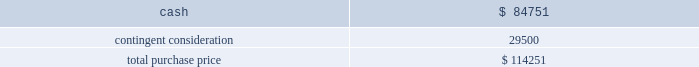Table of contents the company concluded that the acquisition of sentinelle medical did not represent a material business combination , and therefore , no pro forma financial information has been provided herein .
Subsequent to the acquisition date , the company 2019s results of operations include the results of sentinelle medical , which is included within the company 2019s breast health reporting segment .
The company accounted for the sentinelle medical acquisition as a purchase of a business under asc 805 .
The purchase price was comprised of an $ 84.8 million cash payment , which was net of certain adjustments , plus three contingent payments up to a maximum of an additional $ 250.0 million in cash .
The contingent payments are based on a multiple of incremental revenue growth during the two-year period following the completion of the acquisition as follows : six months after acquisition , 12 months after acquisition , and 24 months after acquisition .
Pursuant to asc 805 , the company recorded its estimate of the fair value of the contingent consideration liability based on future revenue projections of the sentinelle medical business under various potential scenarios and weighted probability assumptions of these outcomes .
As of the date of acquisition , these cash flow projections were discounted using a rate of 16.5% ( 16.5 % ) .
The discount rate is based on the weighted-average cost of capital of the acquired business plus a credit risk premium for non-performance risk related to the liability pursuant to asc 820 .
This analysis resulted in an initial contingent consideration liability of $ 29.5 million , which will be adjusted periodically as a component of operating expenses based on changes in the fair value of the liability driven by the accretion of the liability for the time value of money and changes in the assumptions pertaining to the achievement of the defined revenue growth milestones .
This fair value measurement was based on significant inputs not observable in the market and thus represented a level 3 measurement as defined in asc during each quarter in fiscal 2011 , the company has re-evaluated its assumptions and updated the revenue and probability assumptions for future earn-out periods and lowered its projections .
As a result of these adjustments , which were partially offset by the accretion of the liability , and using a current discount rate of approximately 17.0% ( 17.0 % ) , the company recorded a reversal of expense of $ 14.3 million in fiscal 2011 to record the contingent consideration liability at fair value .
In addition , during the second quarter of fiscal 2011 , the first earn-out period ended , and the company adjusted the fair value of the contingent consideration liability for actual results during the earn-out period .
This payment of $ 4.3 million was made in the third quarter of fiscal 2011 .
At september 24 , 2011 , the fair value of the liability is $ 10.9 million .
The company did not issue any equity awards in connection with this acquisition .
The company incurred third-party transaction costs of $ 1.2 million , which were expensed within general and administrative expenses in fiscal 2010 .
The purchase price was as follows: .
Source : hologic inc , 10-k , november 23 , 2011 powered by morningstar ae document research 2120 the information contained herein may not be copied , adapted or distributed and is not warranted to be accurate , complete or timely .
The user assumes all risks for any damages or losses arising from any use of this information , except to the extent such damages or losses cannot be limited or excluded by applicable law .
Past financial performance is no guarantee of future results. .
What percentage of the total purchase price was contingent consideration? 
Rationale: to find the percentage of the total purchase price was contingent consideration , one must divide the contingent consideration by the total purchase price .
Computations: (29500 / 114251)
Answer: 0.2582. 